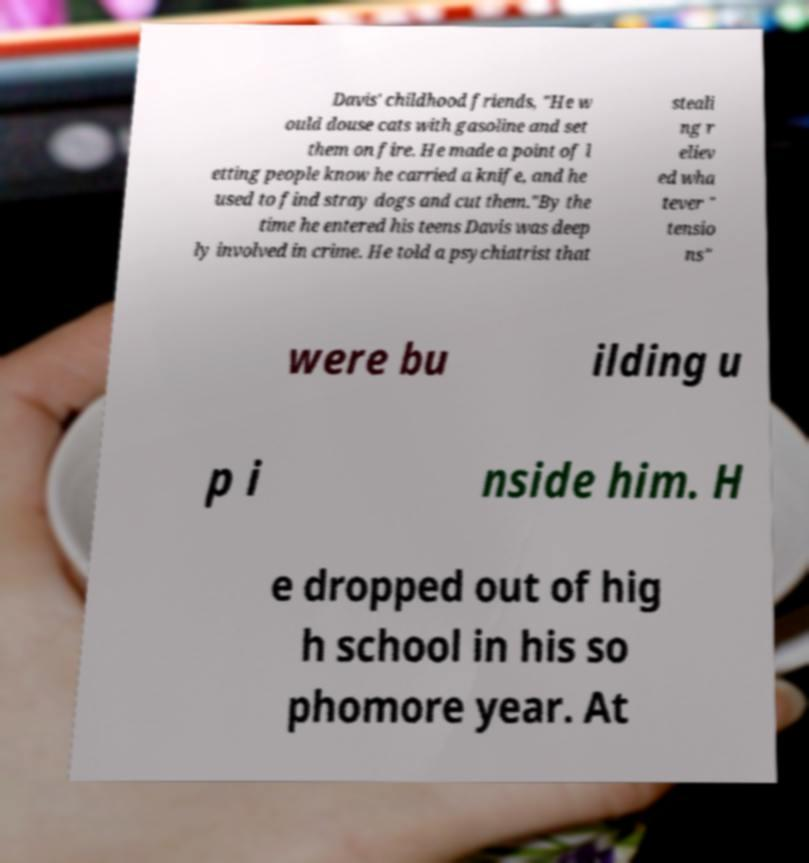For documentation purposes, I need the text within this image transcribed. Could you provide that? Davis' childhood friends, "He w ould douse cats with gasoline and set them on fire. He made a point of l etting people know he carried a knife, and he used to find stray dogs and cut them."By the time he entered his teens Davis was deep ly involved in crime. He told a psychiatrist that steali ng r eliev ed wha tever " tensio ns" were bu ilding u p i nside him. H e dropped out of hig h school in his so phomore year. At 